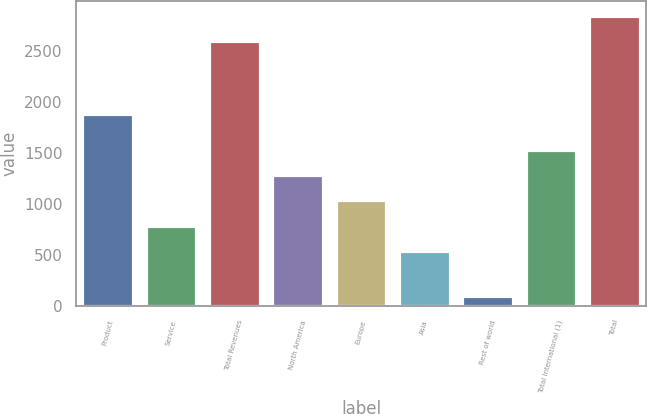Convert chart to OTSL. <chart><loc_0><loc_0><loc_500><loc_500><bar_chart><fcel>Product<fcel>Service<fcel>Total Revenues<fcel>North America<fcel>Europe<fcel>Asia<fcel>Rest of world<fcel>Total International (1)<fcel>Total<nl><fcel>1879<fcel>786.5<fcel>2597<fcel>1285.5<fcel>1036<fcel>537<fcel>102<fcel>1535<fcel>2846.5<nl></chart> 